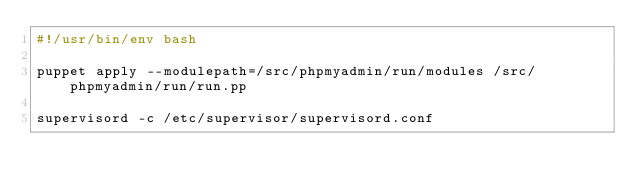Convert code to text. <code><loc_0><loc_0><loc_500><loc_500><_Bash_>#!/usr/bin/env bash

puppet apply --modulepath=/src/phpmyadmin/run/modules /src/phpmyadmin/run/run.pp

supervisord -c /etc/supervisor/supervisord.conf
</code> 